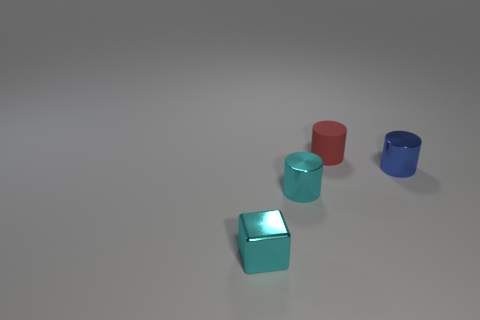What shape is the red object that is the same size as the cyan cylinder?
Provide a succinct answer. Cylinder. Are there fewer metal cubes than metallic cylinders?
Offer a very short reply. Yes. Is there a tiny cyan block that is to the right of the tiny cyan object that is behind the cyan block?
Make the answer very short. No. There is a blue cylinder behind the small cyan thing that is in front of the cyan metallic cylinder; are there any matte cylinders in front of it?
Your answer should be very brief. No. There is a metallic thing right of the tiny red matte cylinder; does it have the same shape as the small cyan object behind the cube?
Your answer should be compact. Yes. What color is the other cylinder that is made of the same material as the small cyan cylinder?
Offer a terse response. Blue. Are there fewer blue objects in front of the tiny cube than metallic things?
Your answer should be compact. Yes. There is a shiny cylinder that is behind the small cyan object that is on the right side of the small cyan shiny object that is on the left side of the small cyan cylinder; what size is it?
Make the answer very short. Small. Is the material of the cylinder in front of the blue thing the same as the tiny cube?
Keep it short and to the point. Yes. What is the material of the cylinder that is the same color as the metallic block?
Provide a short and direct response. Metal. 